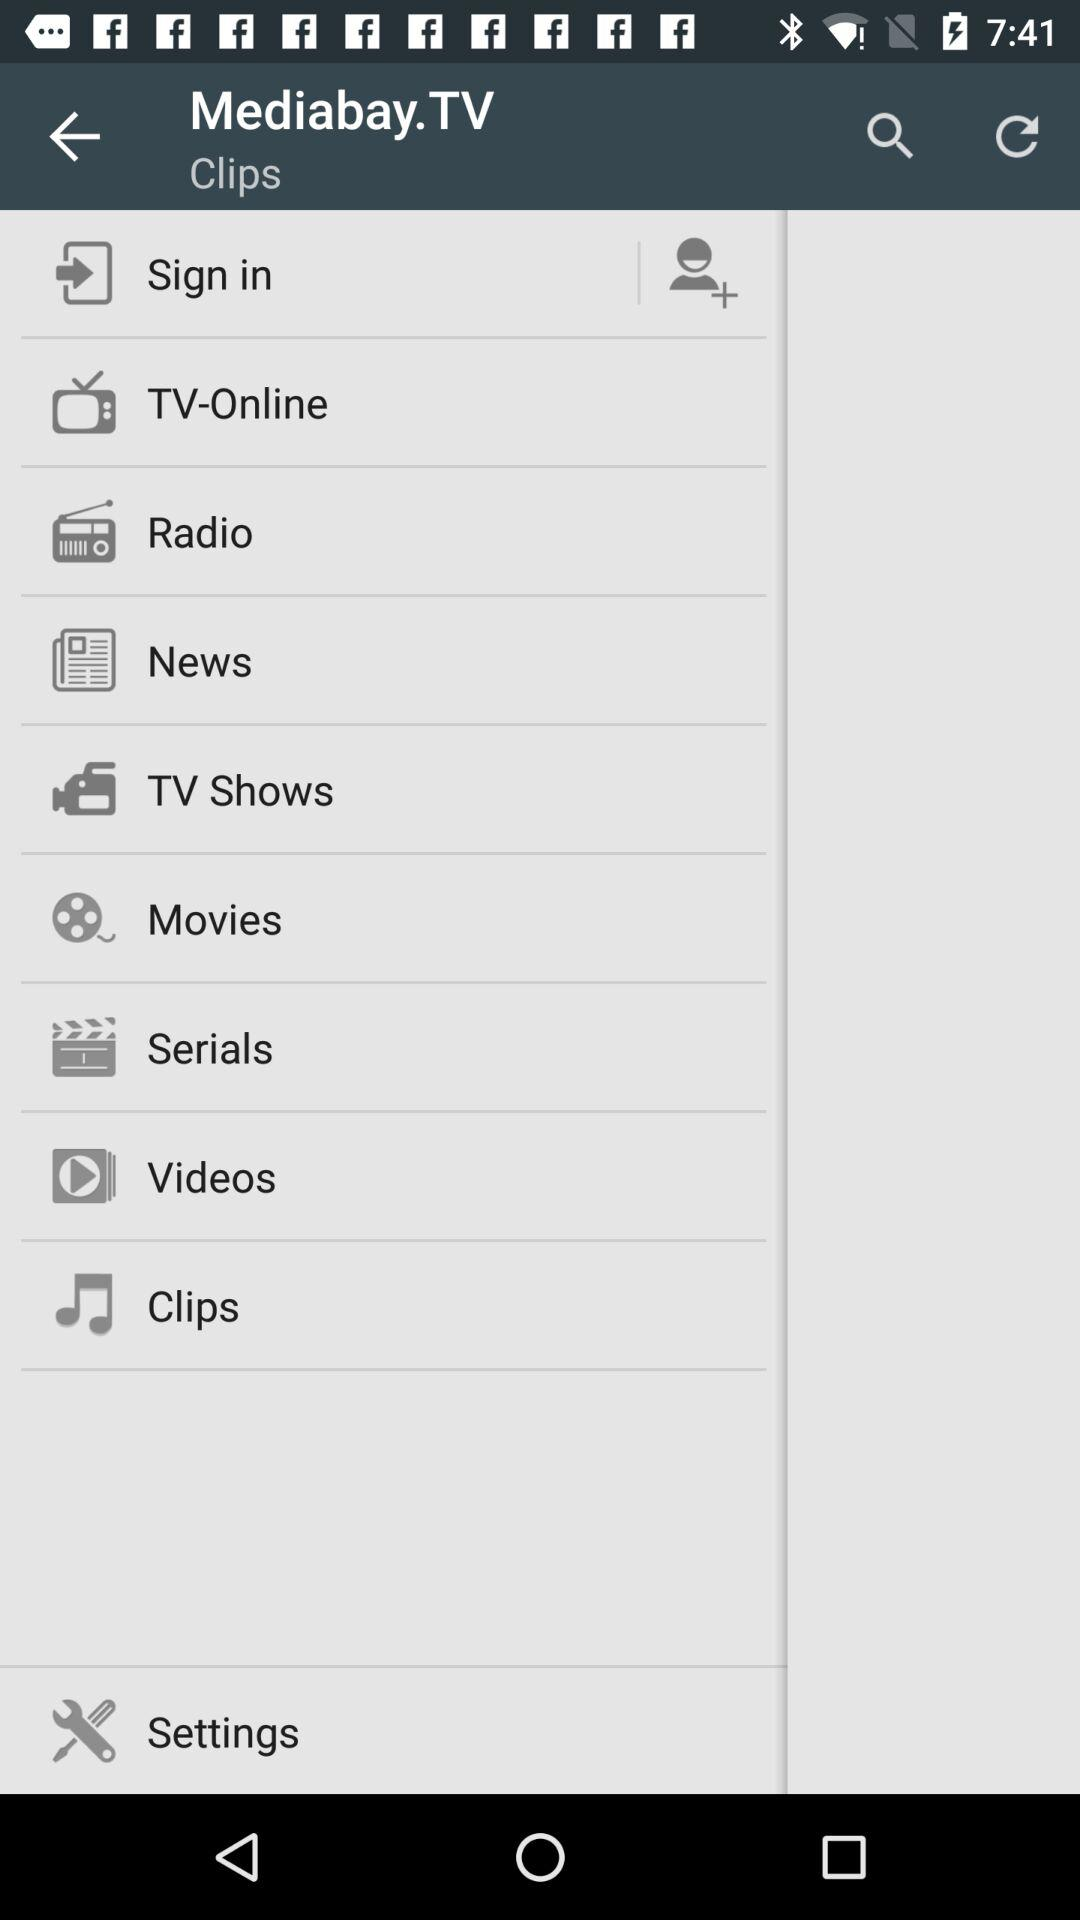What is the name of the application? The name of the application is "Mediabay.TV". 